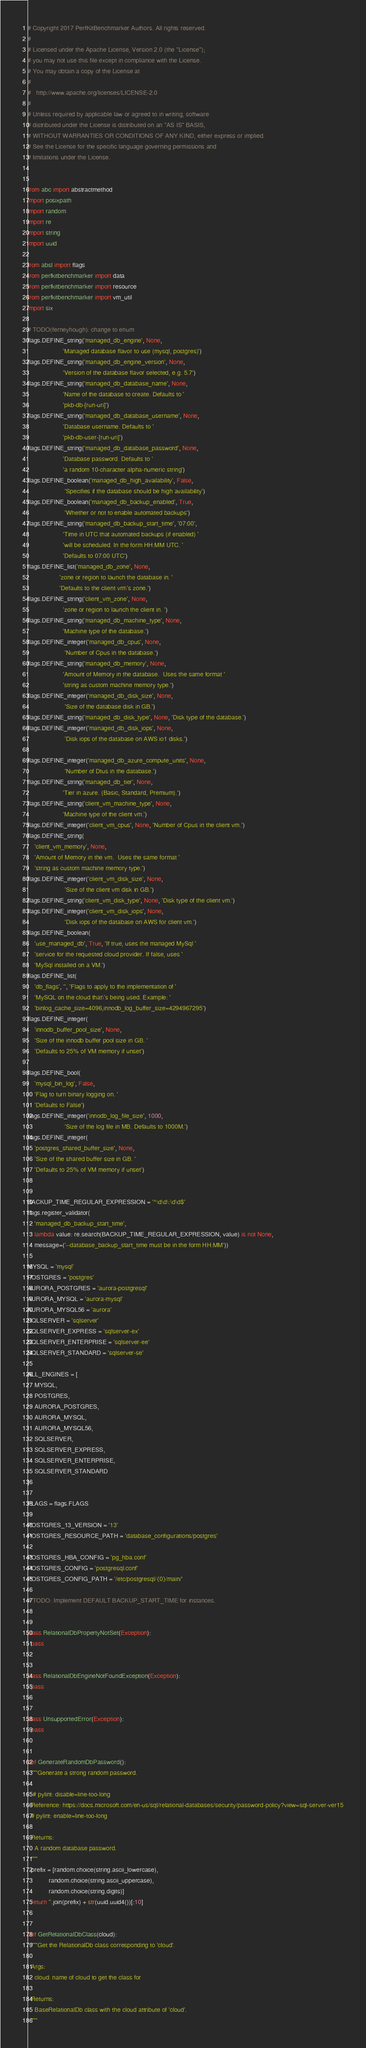Convert code to text. <code><loc_0><loc_0><loc_500><loc_500><_Python_># Copyright 2017 PerfKitBenchmarker Authors. All rights reserved.
#
# Licensed under the Apache License, Version 2.0 (the "License");
# you may not use this file except in compliance with the License.
# You may obtain a copy of the License at
#
#   http://www.apache.org/licenses/LICENSE-2.0
#
# Unless required by applicable law or agreed to in writing, software
# distributed under the License is distributed on an "AS IS" BASIS,
# WITHOUT WARRANTIES OR CONDITIONS OF ANY KIND, either express or implied.
# See the License for the specific language governing permissions and
# limitations under the License.


from abc import abstractmethod
import posixpath
import random
import re
import string
import uuid

from absl import flags
from perfkitbenchmarker import data
from perfkitbenchmarker import resource
from perfkitbenchmarker import vm_util
import six

# TODO(ferneyhough): change to enum
flags.DEFINE_string('managed_db_engine', None,
                    'Managed database flavor to use (mysql, postgres)')
flags.DEFINE_string('managed_db_engine_version', None,
                    'Version of the database flavor selected, e.g. 5.7')
flags.DEFINE_string('managed_db_database_name', None,
                    'Name of the database to create. Defaults to '
                    'pkb-db-[run-uri]')
flags.DEFINE_string('managed_db_database_username', None,
                    'Database username. Defaults to '
                    'pkb-db-user-[run-uri]')
flags.DEFINE_string('managed_db_database_password', None,
                    'Database password. Defaults to '
                    'a random 10-character alpha-numeric string')
flags.DEFINE_boolean('managed_db_high_availability', False,
                     'Specifies if the database should be high availability')
flags.DEFINE_boolean('managed_db_backup_enabled', True,
                     'Whether or not to enable automated backups')
flags.DEFINE_string('managed_db_backup_start_time', '07:00',
                    'Time in UTC that automated backups (if enabled) '
                    'will be scheduled. In the form HH:MM UTC. '
                    'Defaults to 07:00 UTC')
flags.DEFINE_list('managed_db_zone', None,
                  'zone or region to launch the database in. '
                  'Defaults to the client vm\'s zone.')
flags.DEFINE_string('client_vm_zone', None,
                    'zone or region to launch the client in. ')
flags.DEFINE_string('managed_db_machine_type', None,
                    'Machine type of the database.')
flags.DEFINE_integer('managed_db_cpus', None,
                     'Number of Cpus in the database.')
flags.DEFINE_string('managed_db_memory', None,
                    'Amount of Memory in the database.  Uses the same format '
                    'string as custom machine memory type.')
flags.DEFINE_integer('managed_db_disk_size', None,
                     'Size of the database disk in GB.')
flags.DEFINE_string('managed_db_disk_type', None, 'Disk type of the database.')
flags.DEFINE_integer('managed_db_disk_iops', None,
                     'Disk iops of the database on AWS io1 disks.')

flags.DEFINE_integer('managed_db_azure_compute_units', None,
                     'Number of Dtus in the database.')
flags.DEFINE_string('managed_db_tier', None,
                    'Tier in azure. (Basic, Standard, Premium).')
flags.DEFINE_string('client_vm_machine_type', None,
                    'Machine type of the client vm.')
flags.DEFINE_integer('client_vm_cpus', None, 'Number of Cpus in the client vm.')
flags.DEFINE_string(
    'client_vm_memory', None,
    'Amount of Memory in the vm.  Uses the same format '
    'string as custom machine memory type.')
flags.DEFINE_integer('client_vm_disk_size', None,
                     'Size of the client vm disk in GB.')
flags.DEFINE_string('client_vm_disk_type', None, 'Disk type of the client vm.')
flags.DEFINE_integer('client_vm_disk_iops', None,
                     'Disk iops of the database on AWS for client vm.')
flags.DEFINE_boolean(
    'use_managed_db', True, 'If true, uses the managed MySql '
    'service for the requested cloud provider. If false, uses '
    'MySql installed on a VM.')
flags.DEFINE_list(
    'db_flags', '', 'Flags to apply to the implementation of '
    'MySQL on the cloud that\'s being used. Example: '
    'binlog_cache_size=4096,innodb_log_buffer_size=4294967295')
flags.DEFINE_integer(
    'innodb_buffer_pool_size', None,
    'Size of the innodb buffer pool size in GB. '
    'Defaults to 25% of VM memory if unset')

flags.DEFINE_bool(
    'mysql_bin_log', False,
    'Flag to turn binary logging on. '
    'Defaults to False')
flags.DEFINE_integer('innodb_log_file_size', 1000,
                     'Size of the log file in MB. Defaults to 1000M.')
flags.DEFINE_integer(
    'postgres_shared_buffer_size', None,
    'Size of the shared buffer size in GB. '
    'Defaults to 25% of VM memory if unset')


BACKUP_TIME_REGULAR_EXPRESSION = '^\d\d\:\d\d$'
flags.register_validator(
    'managed_db_backup_start_time',
    lambda value: re.search(BACKUP_TIME_REGULAR_EXPRESSION, value) is not None,
    message=('--database_backup_start_time must be in the form HH:MM'))

MYSQL = 'mysql'
POSTGRES = 'postgres'
AURORA_POSTGRES = 'aurora-postgresql'
AURORA_MYSQL = 'aurora-mysql'
AURORA_MYSQL56 = 'aurora'
SQLSERVER = 'sqlserver'
SQLSERVER_EXPRESS = 'sqlserver-ex'
SQLSERVER_ENTERPRISE = 'sqlserver-ee'
SQLSERVER_STANDARD = 'sqlserver-se'

ALL_ENGINES = [
    MYSQL,
    POSTGRES,
    AURORA_POSTGRES,
    AURORA_MYSQL,
    AURORA_MYSQL56,
    SQLSERVER,
    SQLSERVER_EXPRESS,
    SQLSERVER_ENTERPRISE,
    SQLSERVER_STANDARD
]

FLAGS = flags.FLAGS

POSTGRES_13_VERSION = '13'
POSTGRES_RESOURCE_PATH = 'database_configurations/postgres'

POSTGRES_HBA_CONFIG = 'pg_hba.conf'
POSTGRES_CONFIG = 'postgresql.conf'
POSTGRES_CONFIG_PATH = '/etc/postgresql/{0}/main/'

# TODO: Implement DEFAULT BACKUP_START_TIME for instances.


class RelationalDbPropertyNotSet(Exception):
  pass


class RelationalDbEngineNotFoundException(Exception):
  pass


class UnsupportedError(Exception):
  pass


def GenerateRandomDbPassword():
  """Generate a strong random password.

   # pylint: disable=line-too-long
  Reference: https://docs.microsoft.com/en-us/sql/relational-databases/security/password-policy?view=sql-server-ver15
  # pylint: enable=line-too-long

  Returns:
    A random database password.
  """
  prefix = [random.choice(string.ascii_lowercase),
            random.choice(string.ascii_uppercase),
            random.choice(string.digits)]
  return ''.join(prefix) + str(uuid.uuid4())[:10]


def GetRelationalDbClass(cloud):
  """Get the RelationalDb class corresponding to 'cloud'.

  Args:
    cloud: name of cloud to get the class for

  Returns:
    BaseRelationalDb class with the cloud attribute of 'cloud'.
  """</code> 